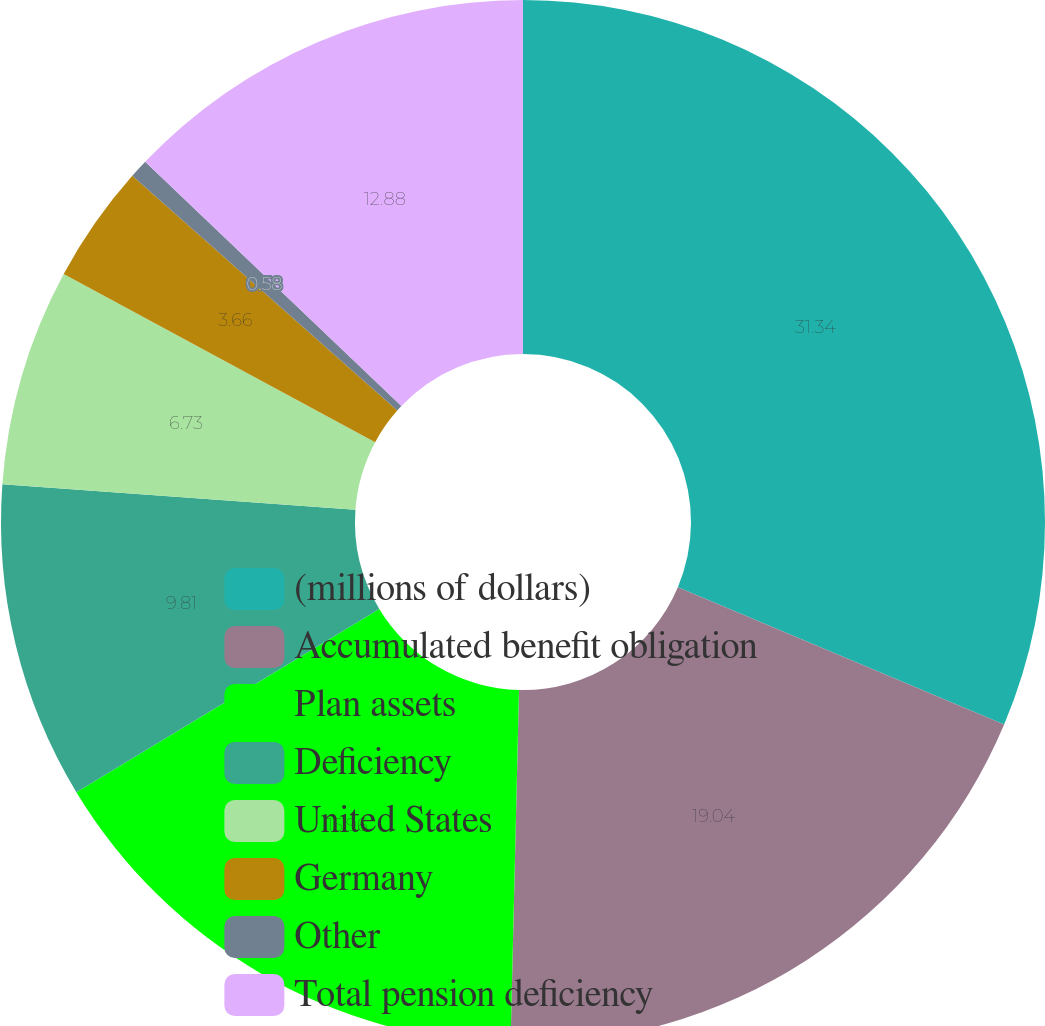Convert chart to OTSL. <chart><loc_0><loc_0><loc_500><loc_500><pie_chart><fcel>(millions of dollars)<fcel>Accumulated benefit obligation<fcel>Plan assets<fcel>Deficiency<fcel>United States<fcel>Germany<fcel>Other<fcel>Total pension deficiency<nl><fcel>31.34%<fcel>19.04%<fcel>15.96%<fcel>9.81%<fcel>6.73%<fcel>3.66%<fcel>0.58%<fcel>12.88%<nl></chart> 